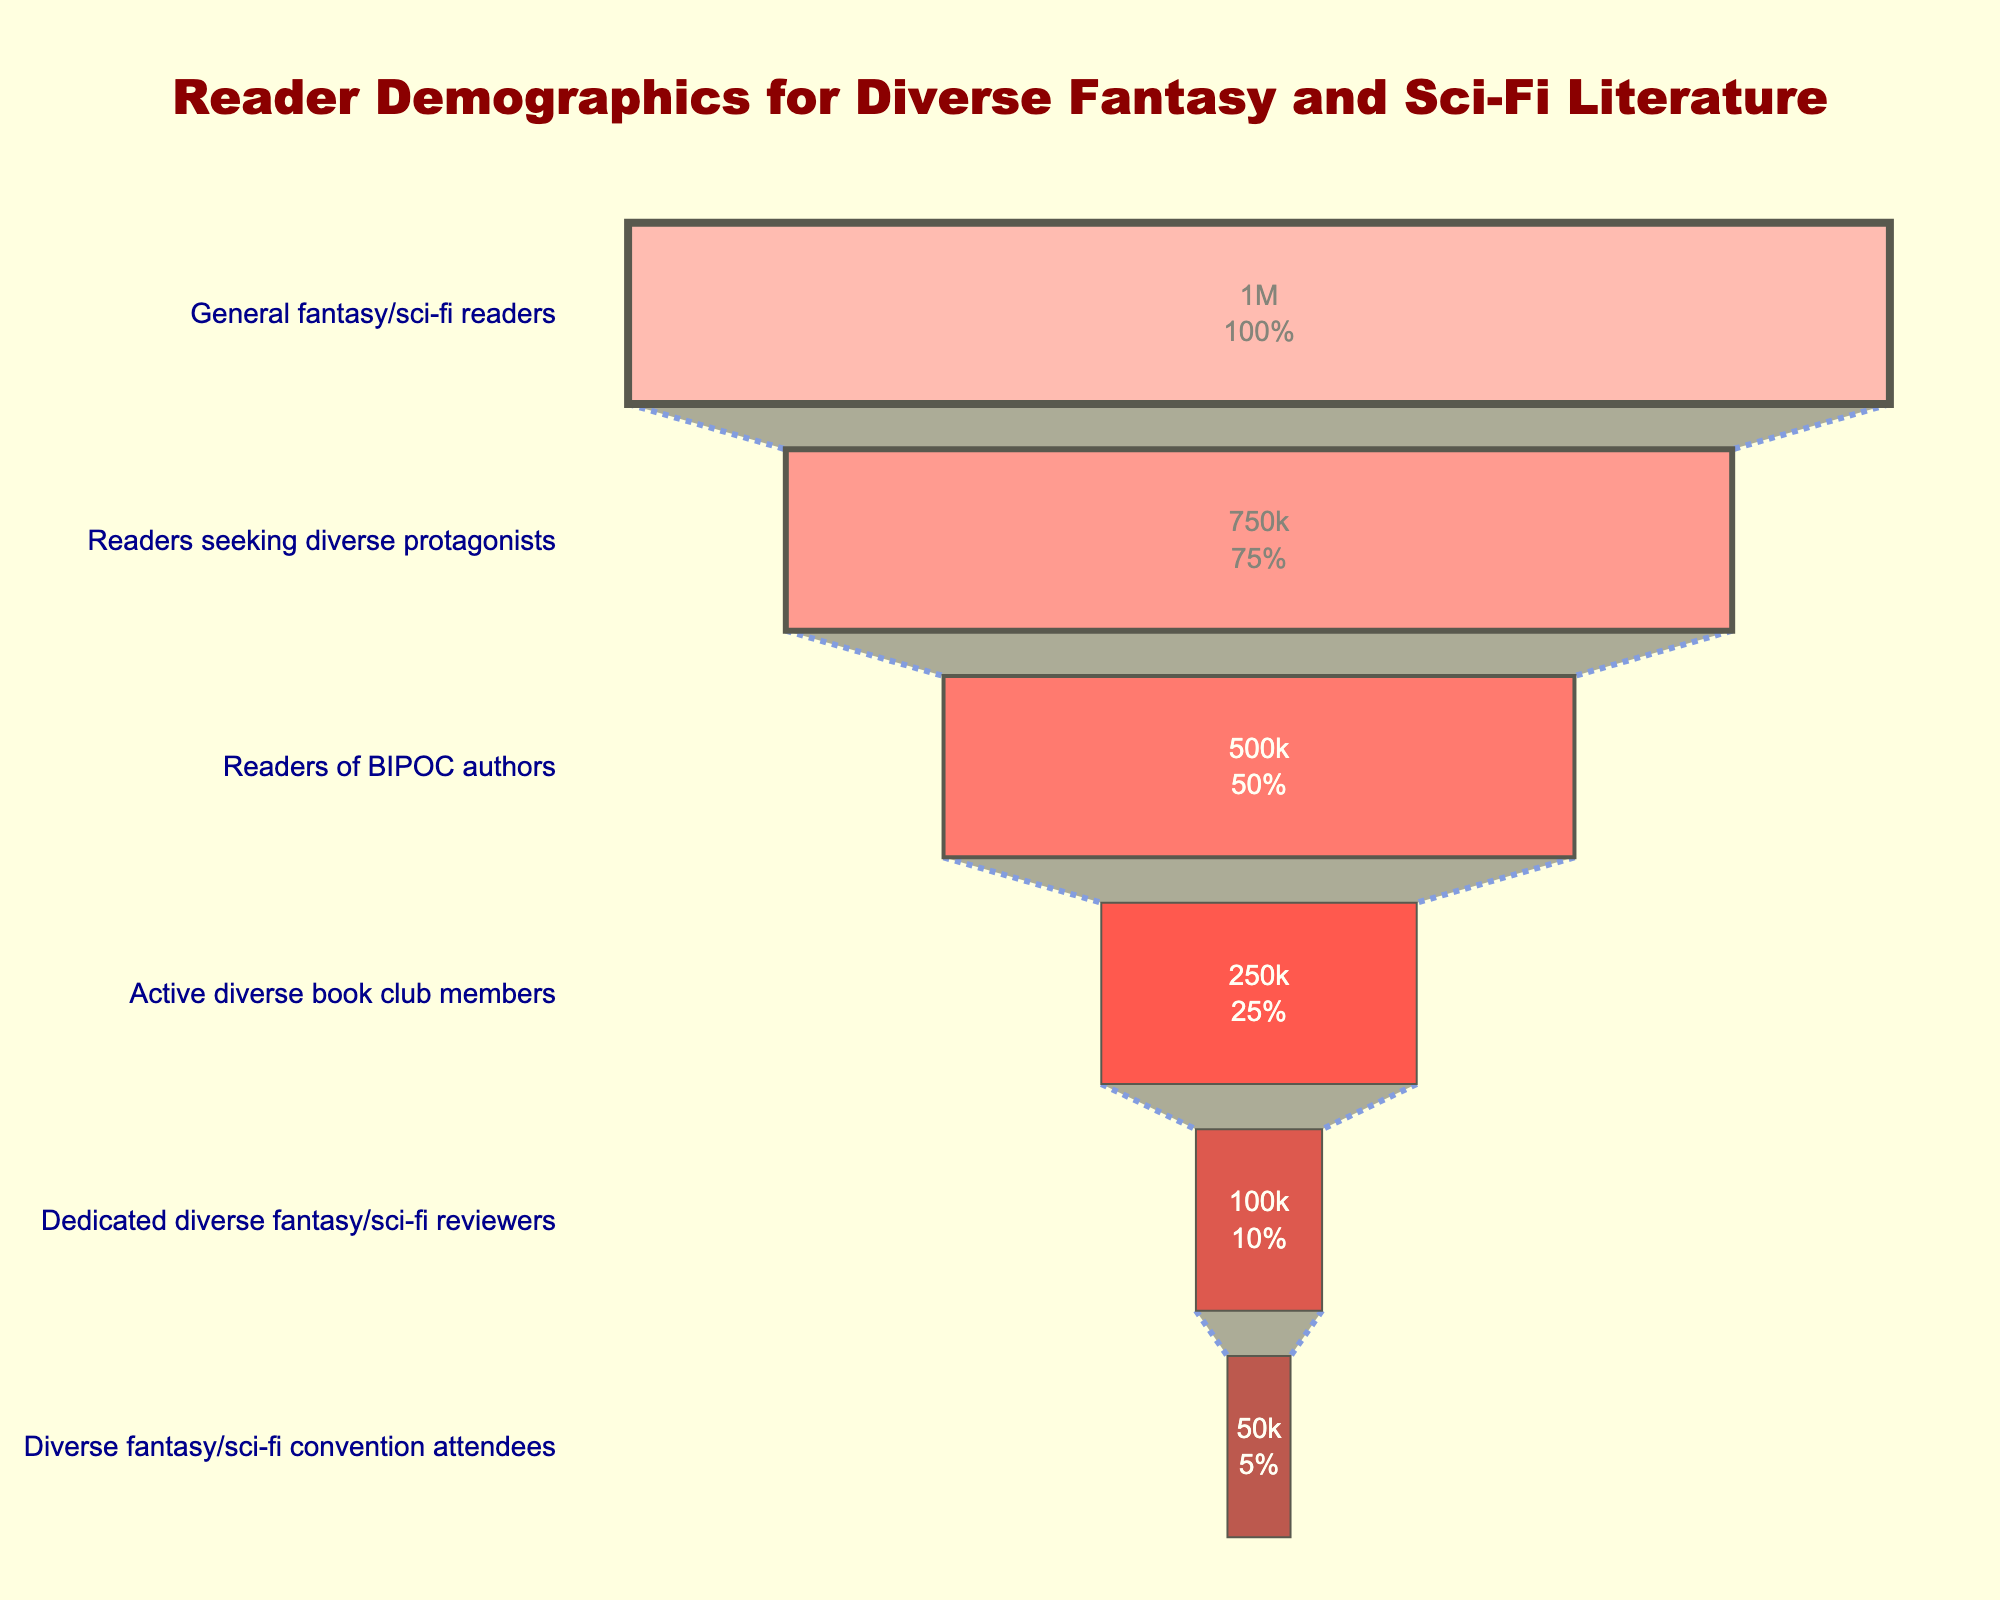What is the title of the funnel chart? Look at the top of the chart where the title is usually placed. The title is centered and in large, dark red font.
Answer: Reader Demographics for Diverse Fantasy and Sci-Fi Literature How many different stages are represented in the funnel chart? Count the number of different stages listed vertically on the chart from top to bottom.
Answer: 6 What is the percentage of readers seeking diverse protagonists out of the general fantasy/sci-fi readers? The number of readers at this stage is 750,000, and the total number of general fantasy/sci-fi readers is 1,000,000. Calculate (750,000 / 1,000,000) * 100.
Answer: 75% Which stage has the fewest number of readers, and what is that number? Look at the stages vertically and identify the one with the smallest number of readers.
Answer: Diverse fantasy/sci-fi convention attendees, 50,000 How many readers are in the middle stage, "Readers of BIPOC authors"? Locate the stage "Readers of BIPOC authors" on the vertical axis and note the number of readers.
Answer: 500,000 What is the combined number of readers in the three largest stages? Add the number of readers in the top three stages: 1,000,000 (General fantasy/sci-fi readers) + 750,000 (Readers seeking diverse protagonists) + 500,000 (Readers of BIPOC authors).
Answer: 2,250,000 Which two stages have a difference of 150,000 readers between them? Compare the number of readers between different pairs of stages until finding the pair with exactly 150,000 readers difference.
Answer: Readers seeking diverse protagonists and Readers of BIPOC authors What is the percentage decrease in readers from "Active diverse book club members" to "Dedicated diverse fantasy/sci-fi reviewers"? Start with 250,000 (Active diverse book club members) and 100,000 (Dedicated diverse fantasy/sci-fi reviewers). Calculate the percentage decrease: ((250,000 - 100,000) / 250,000) * 100.
Answer: 60% Is the number of "Diverse fantasy/sci-fi convention attendees" more or less than half of the "Dedicated diverse fantasy/sci-fi reviewers"? Compare the numbers: 50,000 (Diverse fantasy/sci-fi convention attendees) and 100,000 (Dedicated diverse fantasy/sci-fi reviewers).
Answer: Less What color is used to represent the "General fantasy/sci-fi readers" stage? Observe the color assigned to the top stage of the funnel chart.
Answer: Light pink 